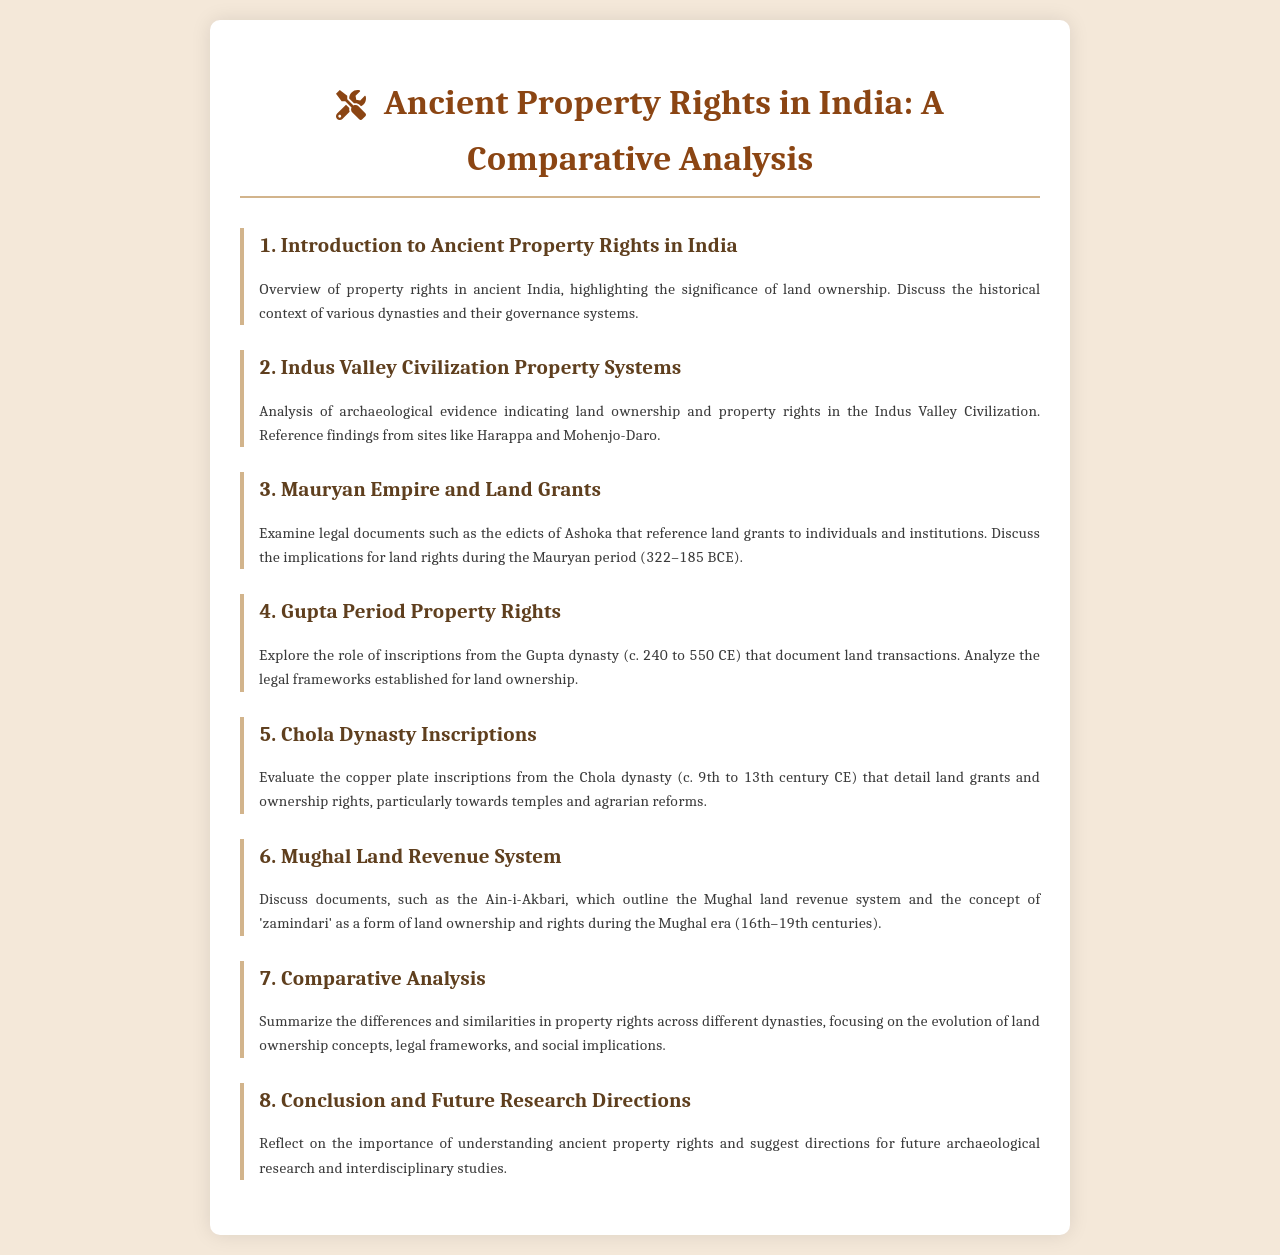What is the main topic of the document? The main topic discussed in the document is the comparative analysis of ancient property rights across Indian dynasties.
Answer: Ancient Property Rights in India: A Comparative Analysis What period does the Mauryan Empire cover? The document states that the Mauryan period spans from 322 to 185 BCE.
Answer: 322–185 BCE Which civilization's property systems are analyzed in the document? The document analyzes the property systems of the Indus Valley Civilization.
Answer: Indus Valley Civilization What is the primary source mentioned for the Mughal land revenue system? The Ain-i-Akbari is mentioned as the primary source for the Mughal land revenue system.
Answer: Ain-i-Akbari What type of inscriptions are evaluated from the Chola Dynasty? The document discusses copper plate inscriptions related to land grants and ownership rights.
Answer: Copper plate inscriptions During which period was the Gupta Dynasty active? The Gupta dynasty is noted to have been active around c. 240 to 550 CE.
Answer: c. 240 to 550 CE What is one focus of the conclusion section in the document? The conclusion reflects on the importance of understanding ancient property rights.
Answer: Importance of understanding ancient property rights What does the schedule suggest as a future research direction? The document suggests interdisciplinary studies as a direction for future research.
Answer: Interdisciplinary studies 